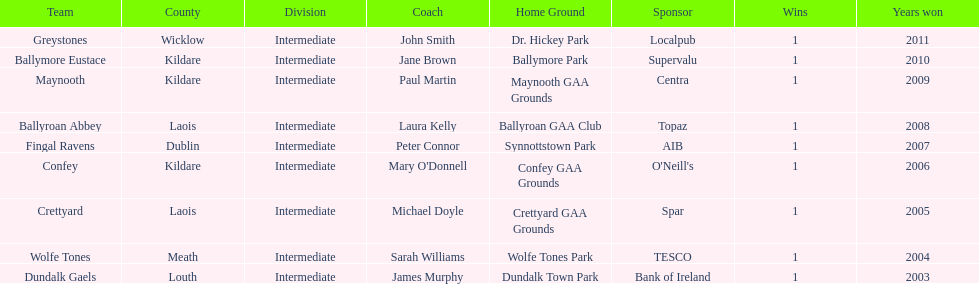Which county had the most number of wins? Kildare. 